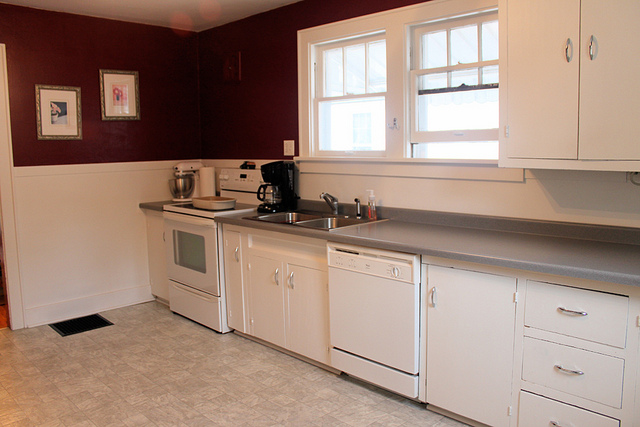Where is the oven located in relation to the sink? The oven is located to the left of the sink, providing convenient access while cooking. 